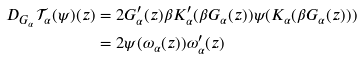<formula> <loc_0><loc_0><loc_500><loc_500>D _ { G _ { \alpha } } \mathcal { T } _ { \alpha } ( \psi ) ( z ) & = 2 G _ { \alpha } ^ { \prime } ( z ) \beta K _ { \alpha } ^ { \prime } ( \beta G _ { \alpha } ( z ) ) \psi ( K _ { \alpha } ( \beta G _ { \alpha } ( z ) ) ) \\ & = 2 \psi ( \omega _ { \alpha } ( z ) ) \omega _ { \alpha } ^ { \prime } ( z )</formula> 